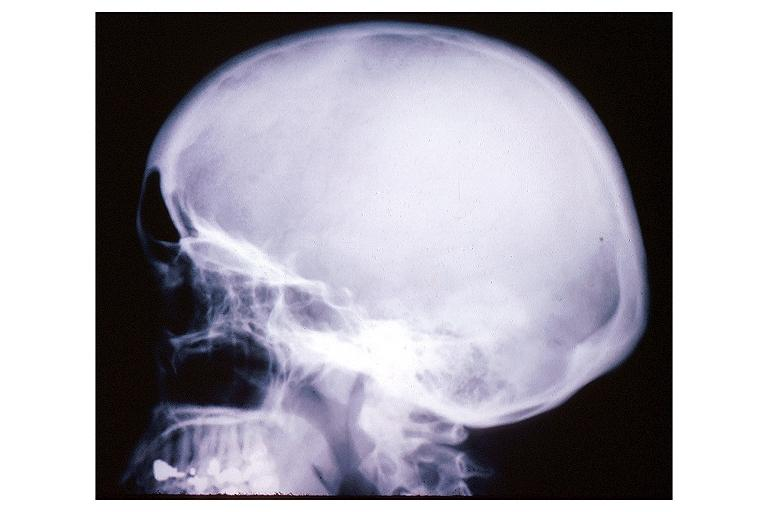s oral present?
Answer the question using a single word or phrase. Yes 